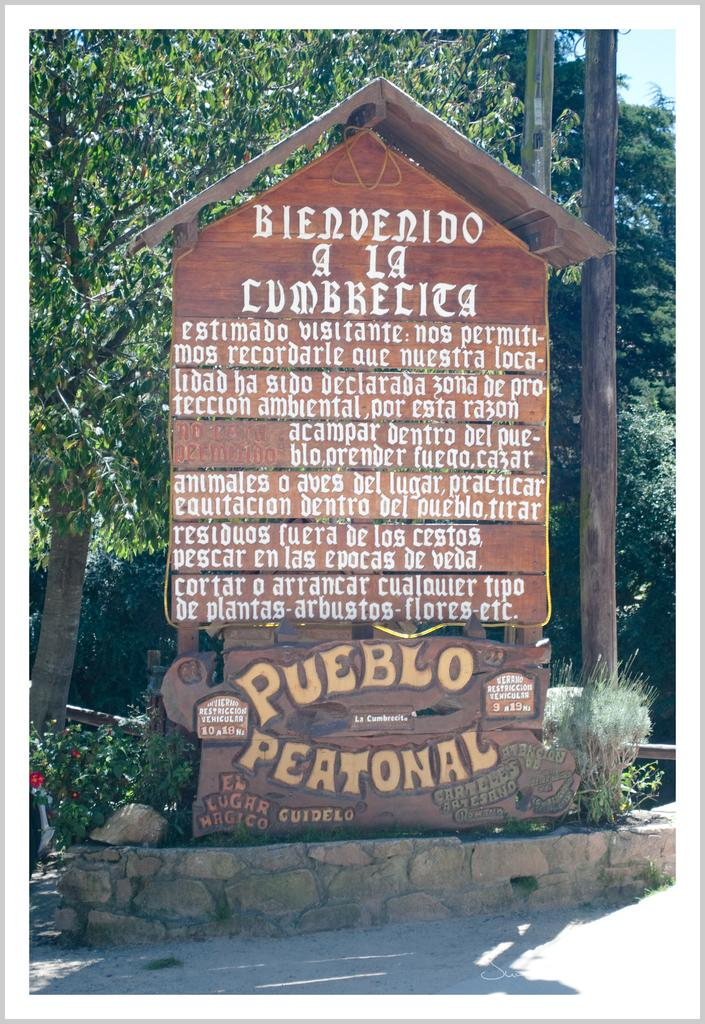What is the main subject in the middle of the image? There is a board with text written on it in the middle of the image. What type of natural scenery can be seen in the image? There are trees visible at the back side of the image. What is visible at the top of the image? The sky is visible at the top of the image. Can you tell me how many bags are hanging on the trees in the image? There are no bags present in the image; it only features a board with text and trees in the background. 